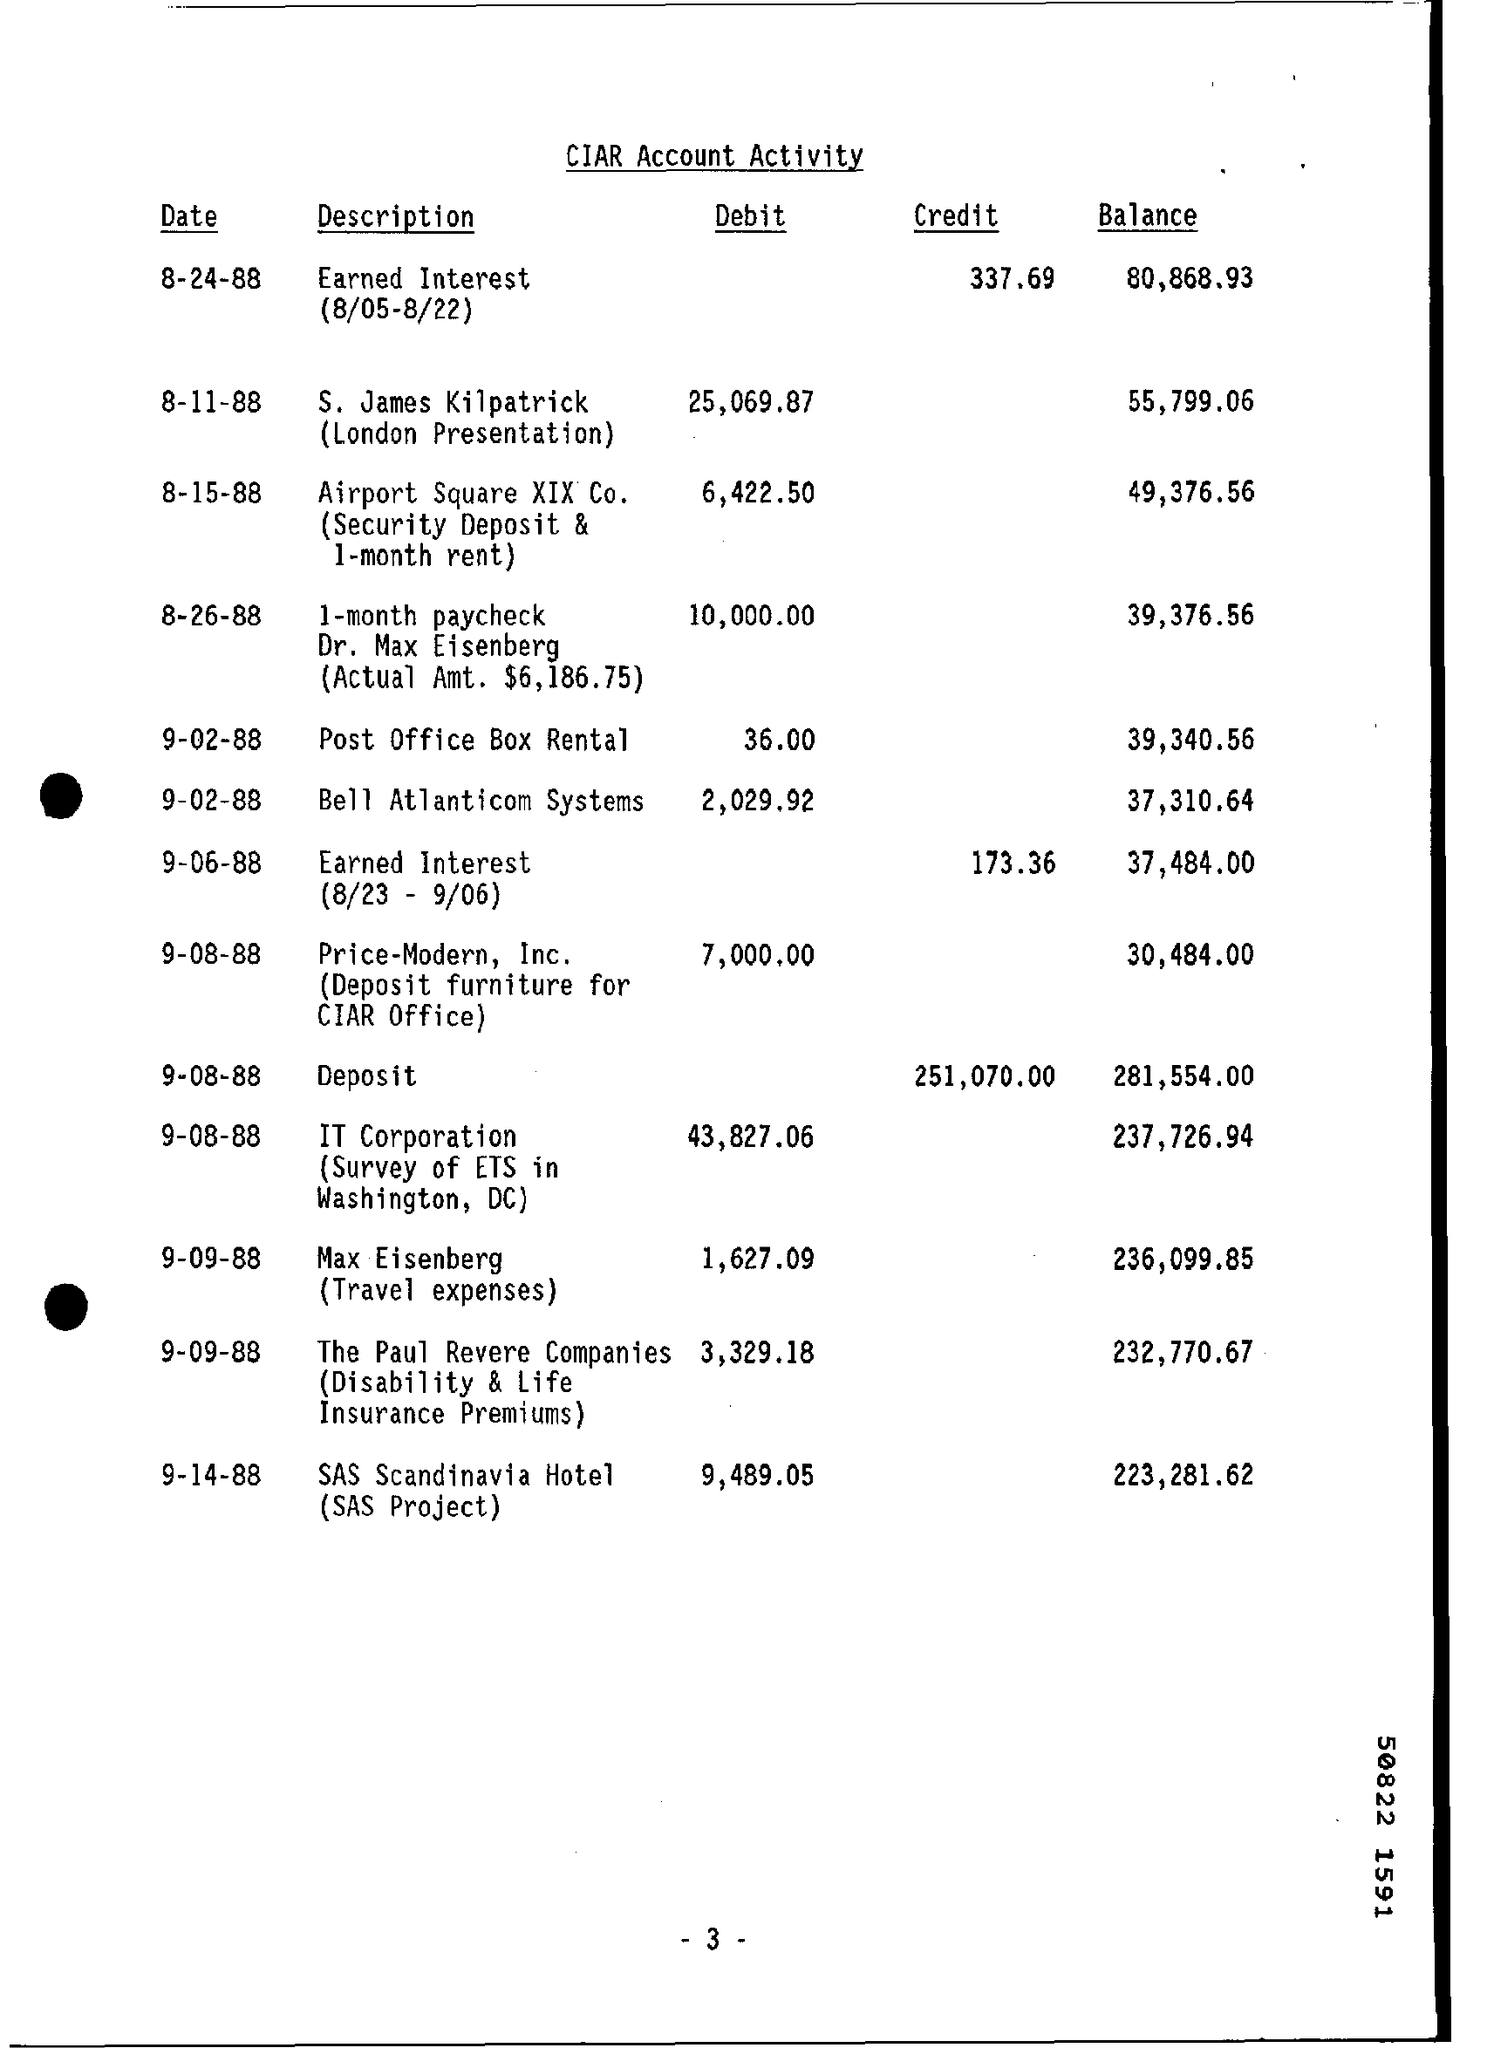Mention a couple of crucial points in this snapshot. On September 14, 1988, the balance amount of SAS Scandinavia Hotel was 223,281.62. As of September 2, 1988, the balance amount of Bell Atlanticom systems was $37,310.64. On February 9, 1988, the amount of $36.00 was debited for post office box rental. On August 9th, 1988, IT Corporation debited an amount of 43,827.06. On September 9, 1988, the balance amount of Paul Revere companies was $232,770.67. 